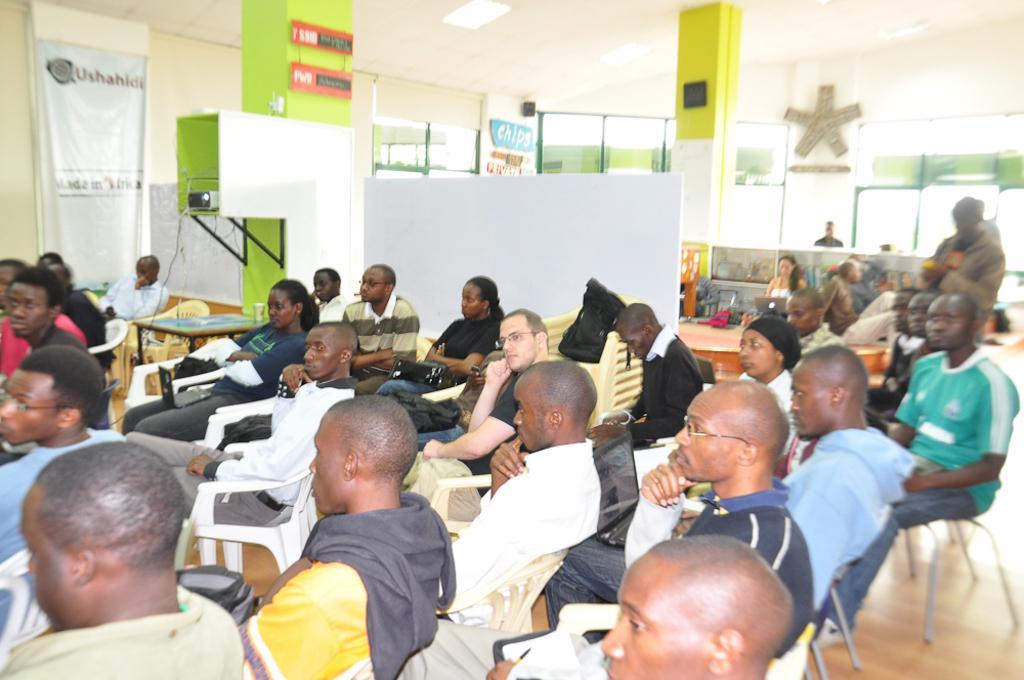Please provide a concise description of this image. In the image we can see there are lot of people who are sitting on chair and in between there is a pillar. 